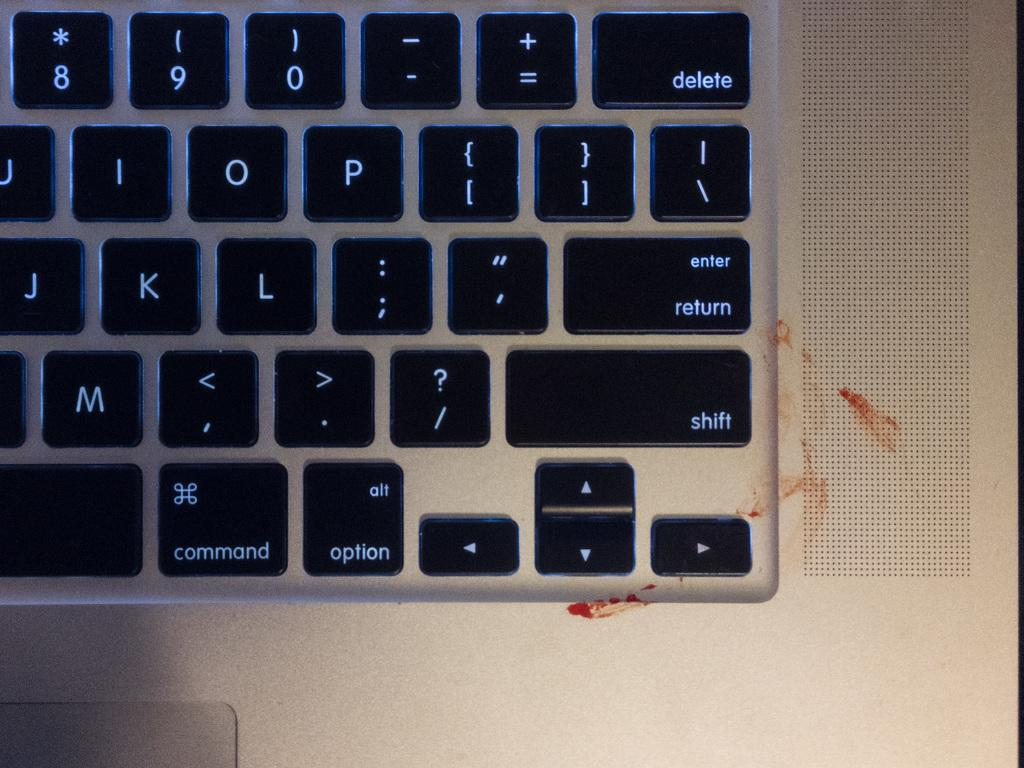<image>
Provide a brief description of the given image. Among the keys on this keyboard are delete, return and shift. 